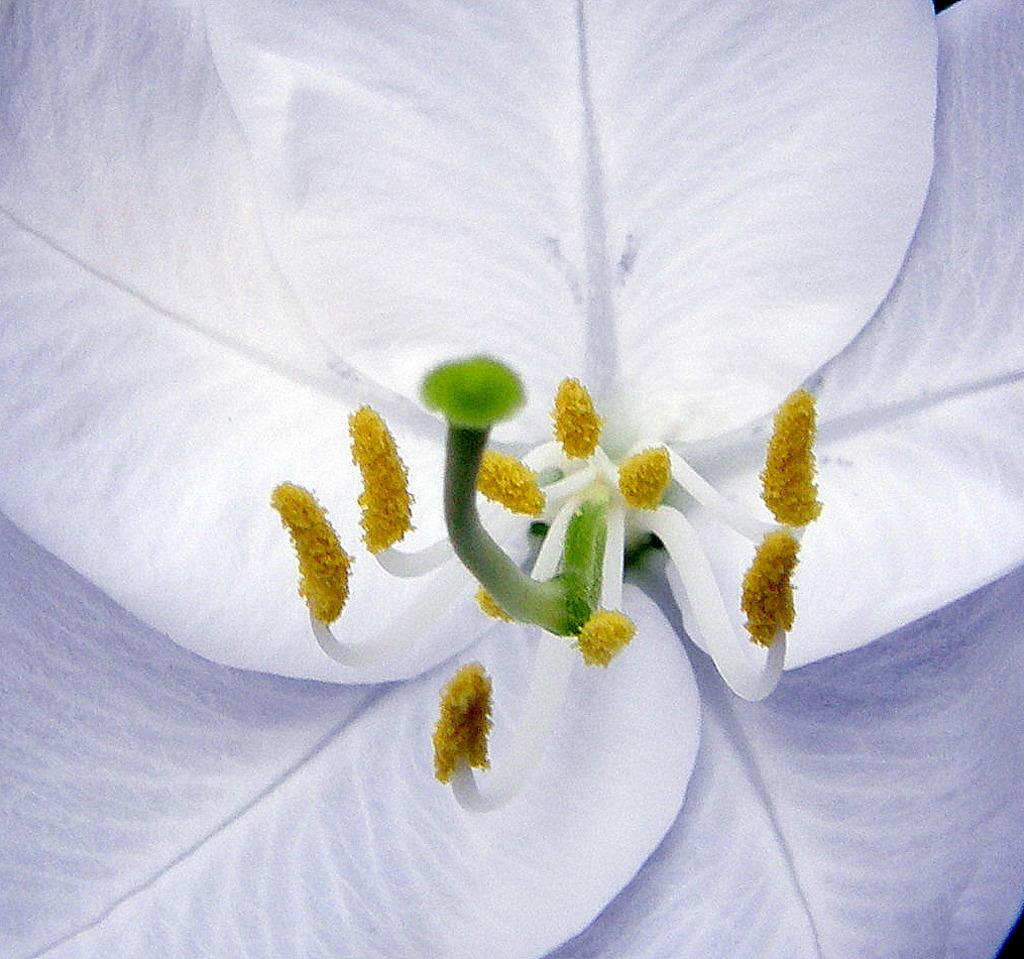What is the color of the petals of the flower in the image? The flower has white color petals. What is the color of the filaments of the flower in the image? The flower has white color filaments. What is the color of the anthers of the flower in the image? The flower has yellow color anthers. What is the color of the stigma of the flower in the image? The flower has green color stigma. What is the color of the style of the flower in the image? The flower has green color style. Can you see a kitty playing with the flower in the image? There is no kitty present in the image, and therefore no such activity can be observed. 